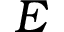<formula> <loc_0><loc_0><loc_500><loc_500>E</formula> 